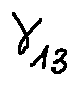<formula> <loc_0><loc_0><loc_500><loc_500>\gamma _ { 1 3 }</formula> 